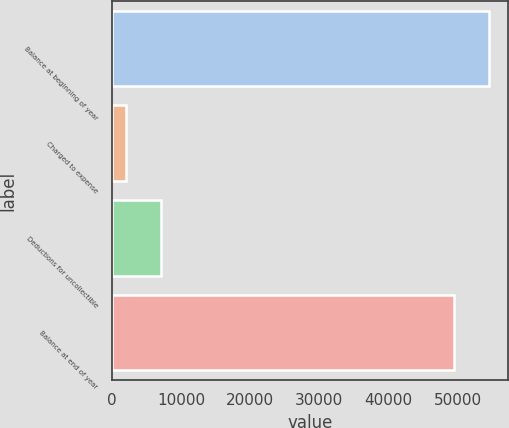Convert chart to OTSL. <chart><loc_0><loc_0><loc_500><loc_500><bar_chart><fcel>Balance at beginning of year<fcel>Charged to expense<fcel>Deductions for uncollectible<fcel>Balance at end of year<nl><fcel>54576.2<fcel>1988<fcel>7045.2<fcel>49519<nl></chart> 